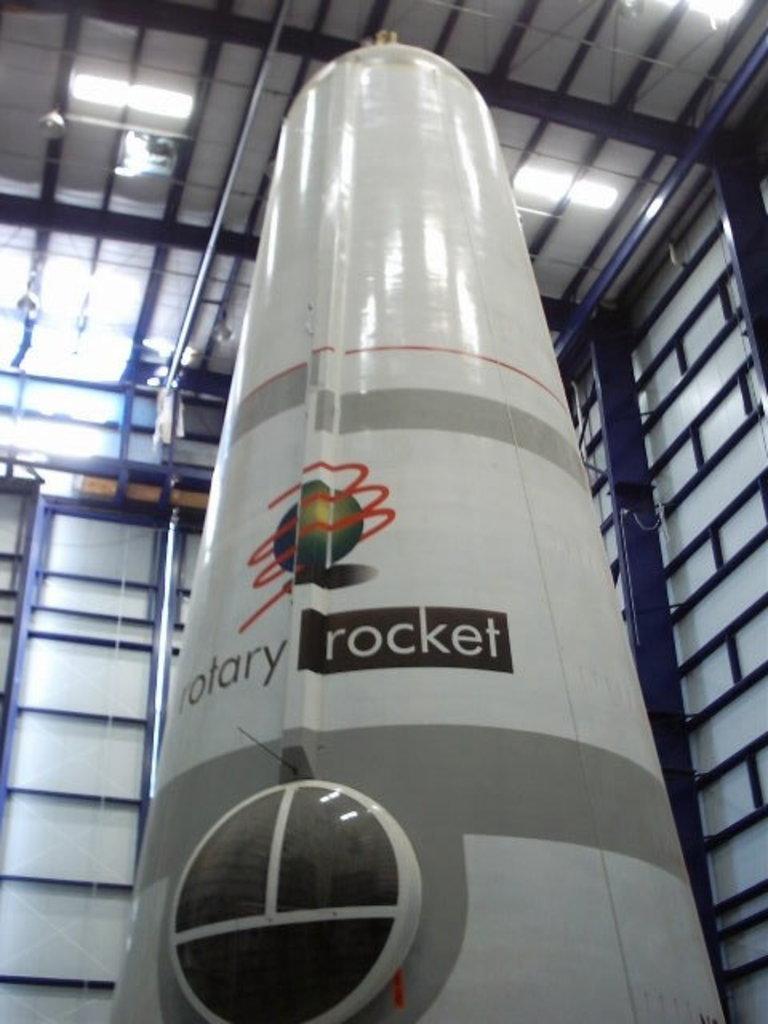How would you summarize this image in a sentence or two? In this picture I can see a thing in front, which looks like rocket and I see something is written on it. In the background I can see number of rods and I can see the lights. 